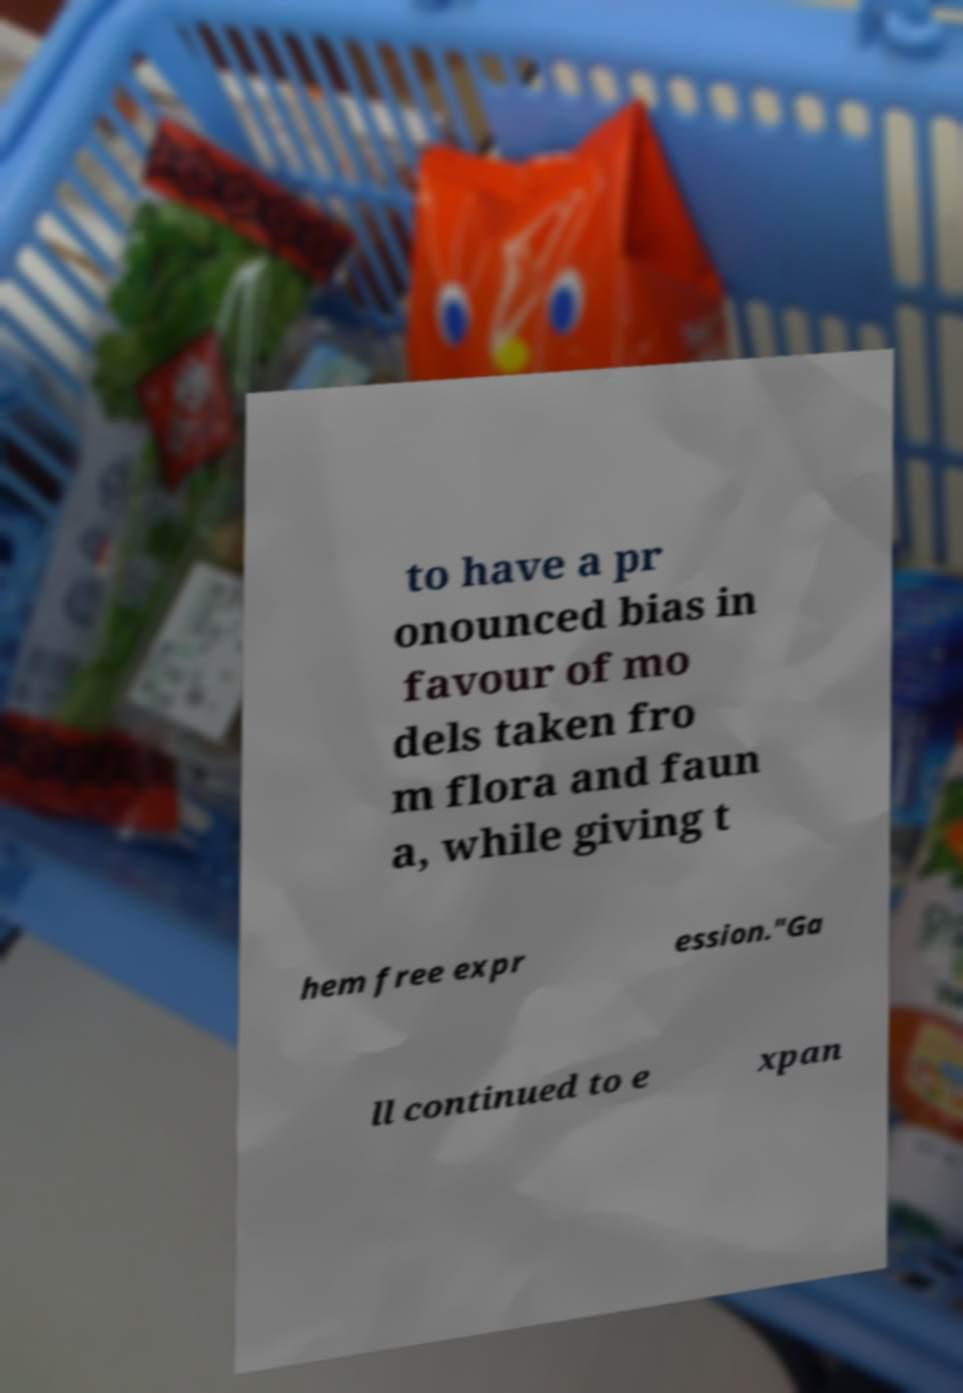Can you accurately transcribe the text from the provided image for me? to have a pr onounced bias in favour of mo dels taken fro m flora and faun a, while giving t hem free expr ession."Ga ll continued to e xpan 